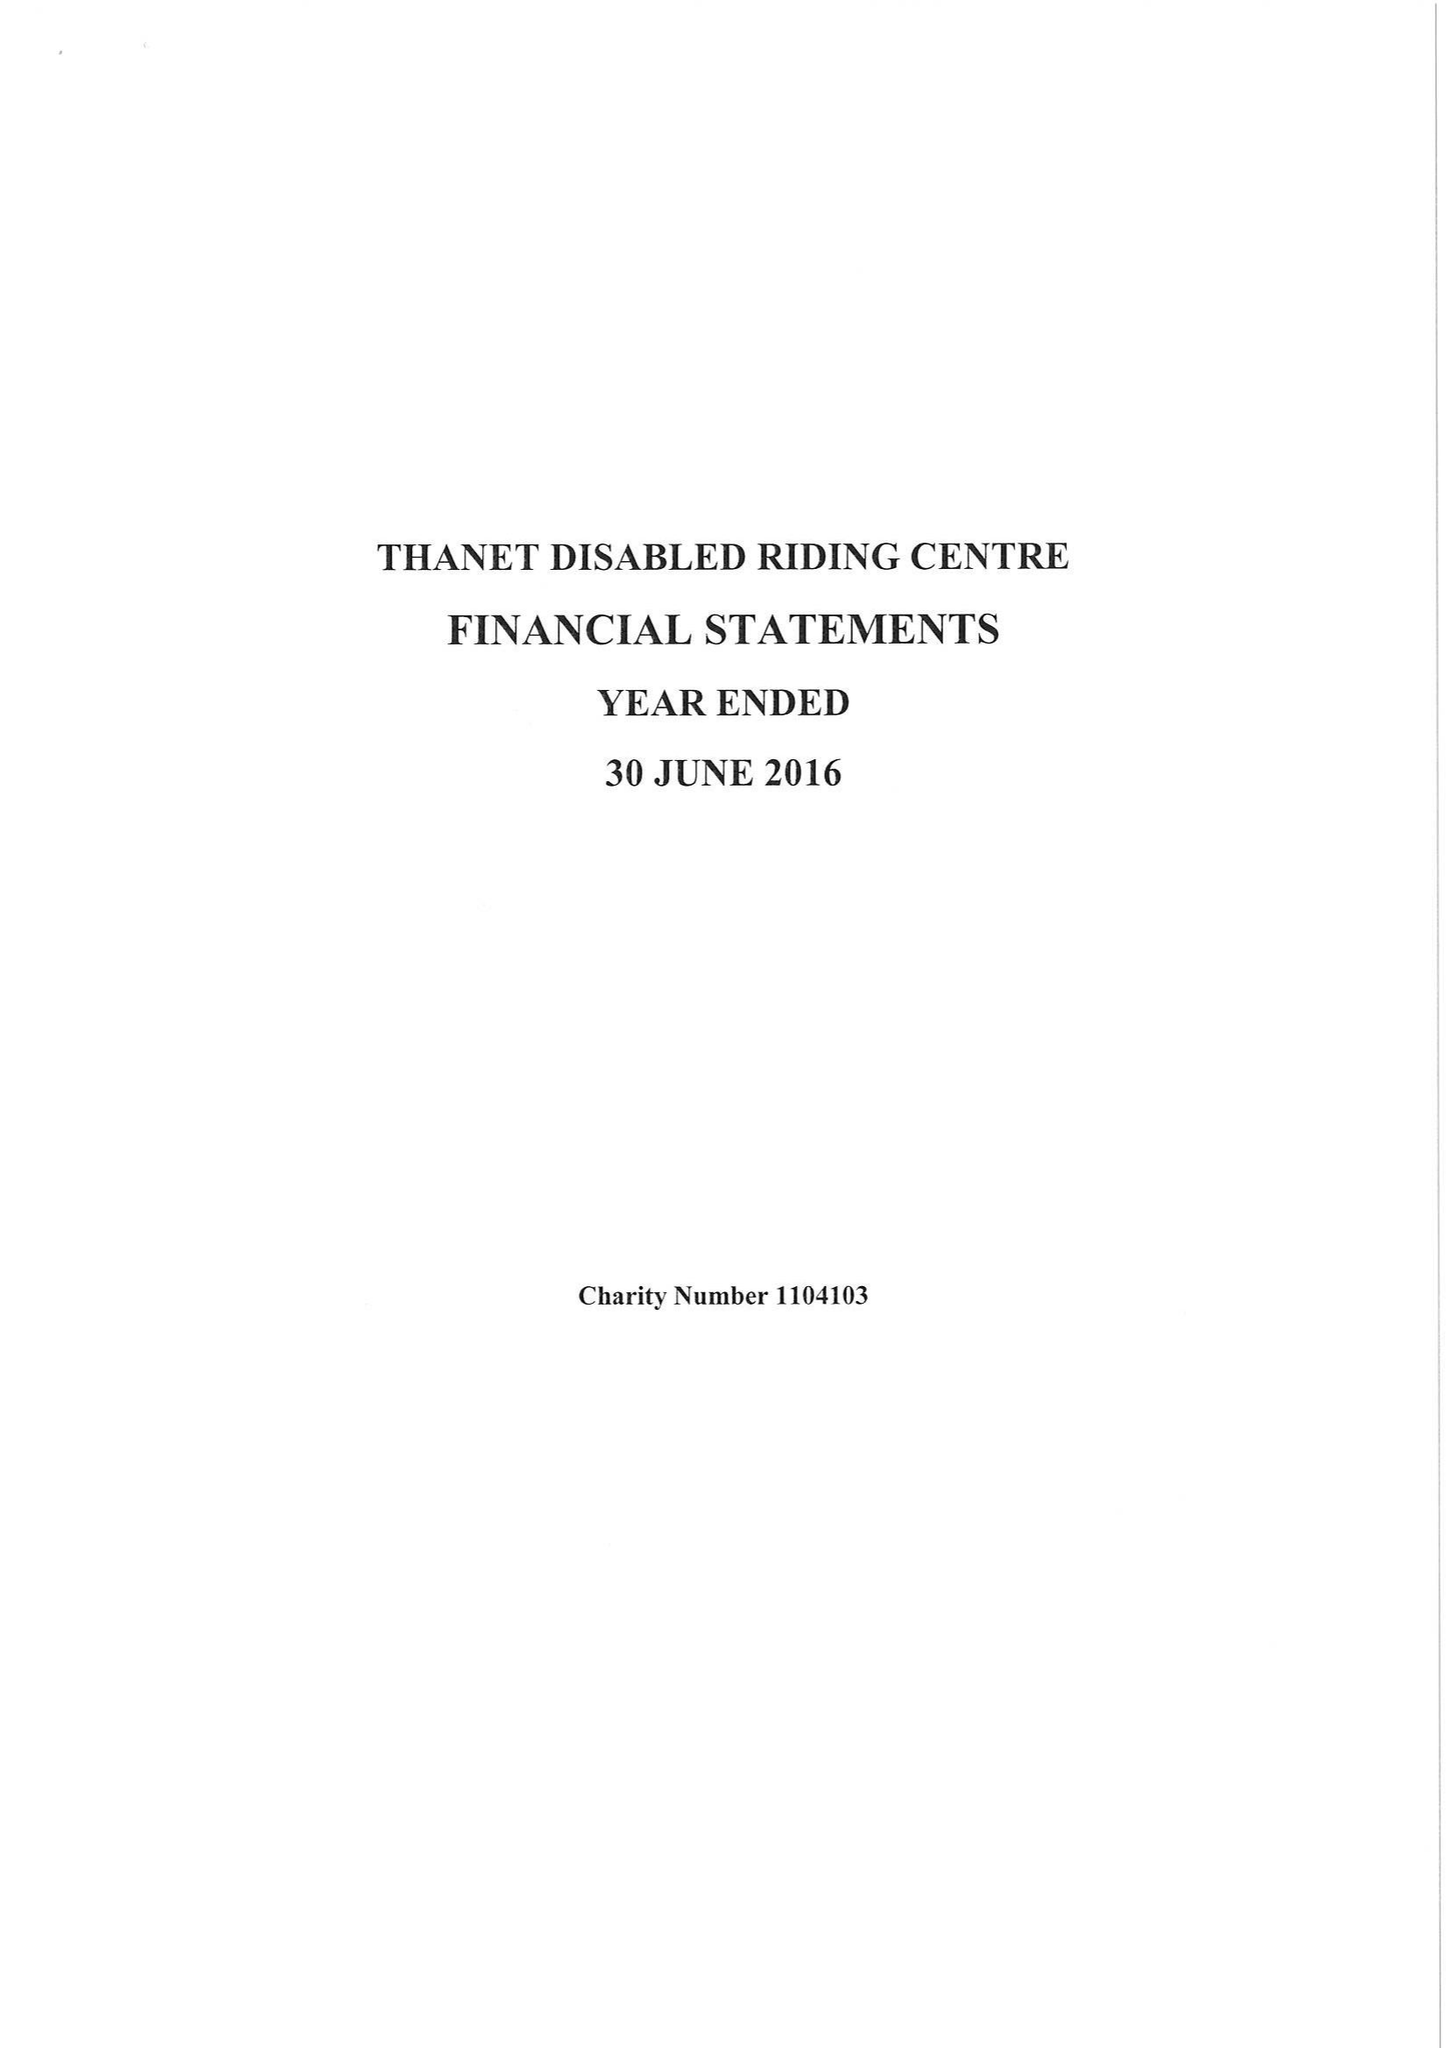What is the value for the report_date?
Answer the question using a single word or phrase. 2016-06-30 